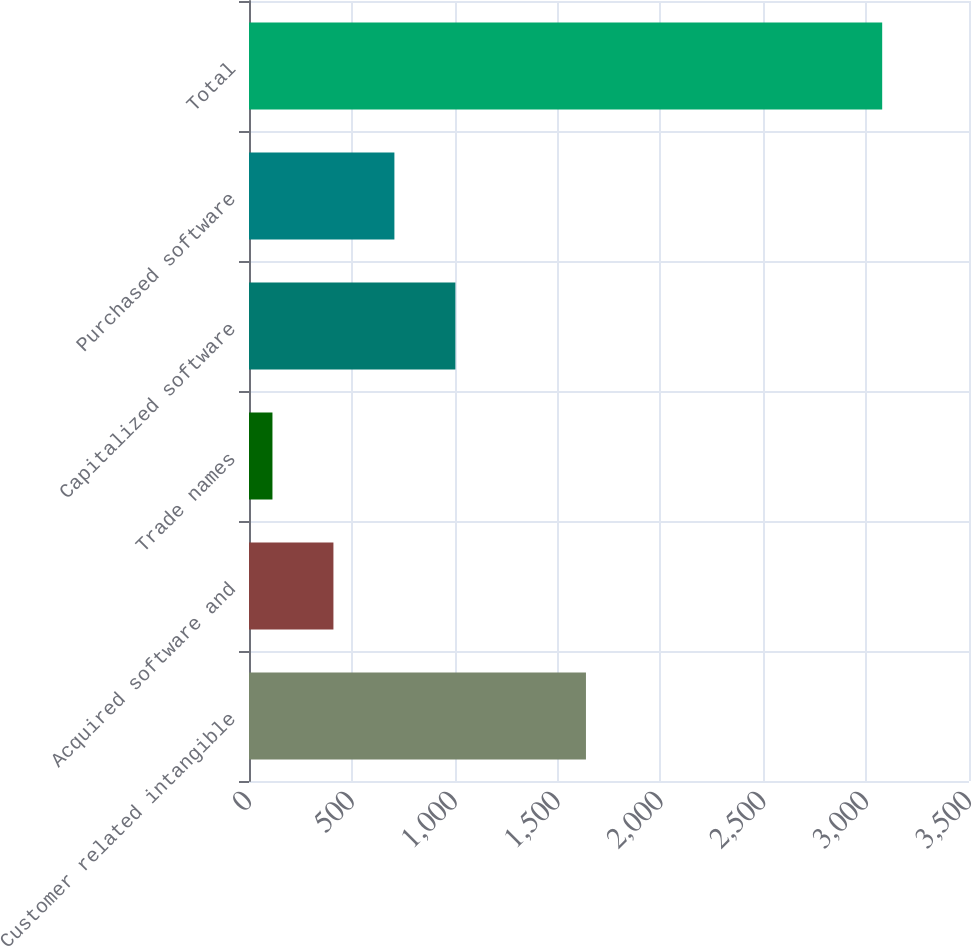<chart> <loc_0><loc_0><loc_500><loc_500><bar_chart><fcel>Customer related intangible<fcel>Acquired software and<fcel>Trade names<fcel>Capitalized software<fcel>Purchased software<fcel>Total<nl><fcel>1638<fcel>410.4<fcel>114<fcel>1003.2<fcel>706.8<fcel>3078<nl></chart> 